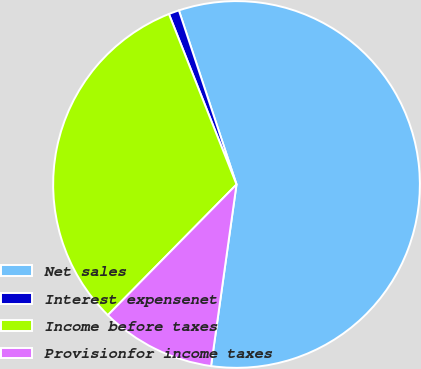<chart> <loc_0><loc_0><loc_500><loc_500><pie_chart><fcel>Net sales<fcel>Interest expensenet<fcel>Income before taxes<fcel>Provisionfor income taxes<nl><fcel>57.3%<fcel>0.92%<fcel>31.61%<fcel>10.16%<nl></chart> 